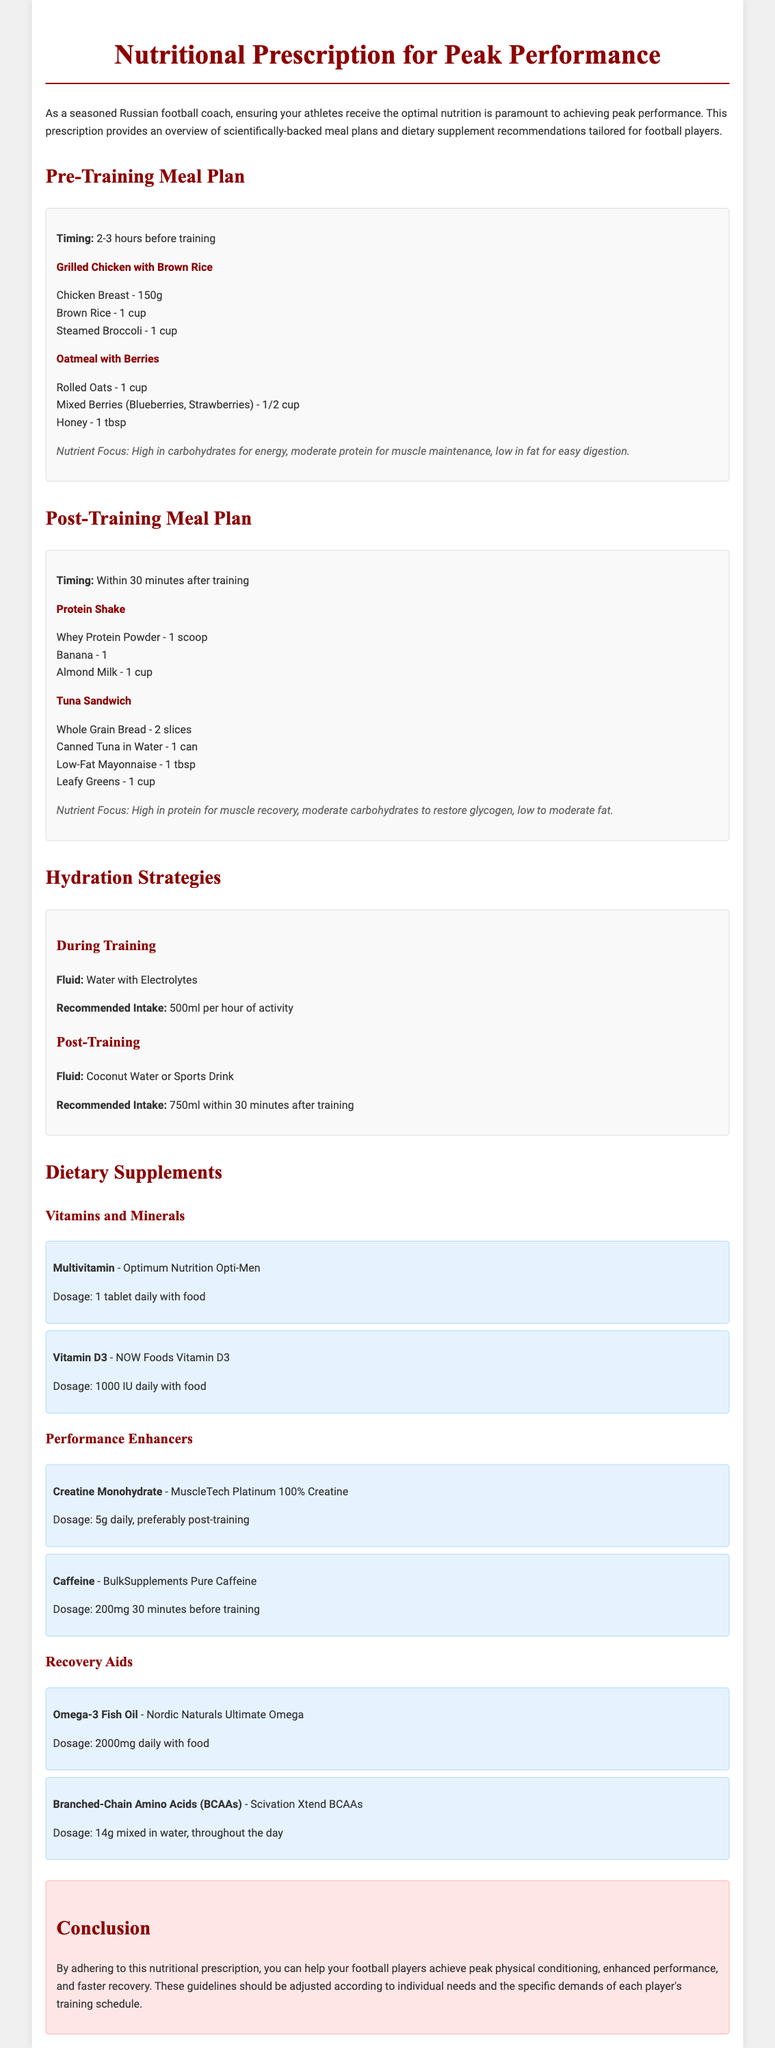what is the first meal recommended before training? The first meal listed in the pre-training meal plan is Grilled Chicken with Brown Rice.
Answer: Grilled Chicken with Brown Rice how much whey protein powder is suggested for a post-training meal? The document states that 1 scoop of Whey Protein Powder is recommended for a post-training meal.
Answer: 1 scoop what is the recommended intake of water with electrolytes during training? The document specifies a recommended intake of 500ml per hour of activity for water with electrolytes.
Answer: 500ml how many grams of creatine monohydrate should be taken daily? The document indicates a daily dosage of 5 grams of Creatine Monohydrate.
Answer: 5g what is the nutrient focus of the post-training meal? The nutrient focus of the post-training meal is high in protein for muscle recovery.
Answer: High in protein for muscle recovery what type of oil is suggested as a recovery aid? The document mentions Omega-3 Fish Oil as a recovery aid.
Answer: Omega-3 Fish Oil which meal contains mixed berries? The meal containing mixed berries is Oatmeal with Berries.
Answer: Oatmeal with Berries how long before training should the pre-training meal be consumed? The document recommends consuming the pre-training meal 2-3 hours before training.
Answer: 2-3 hours what is the purpose of this nutritional prescription document? The purpose is to provide meal plans and dietary supplement recommendations for peak performance in football players.
Answer: Provide meal plans and dietary supplement recommendations 